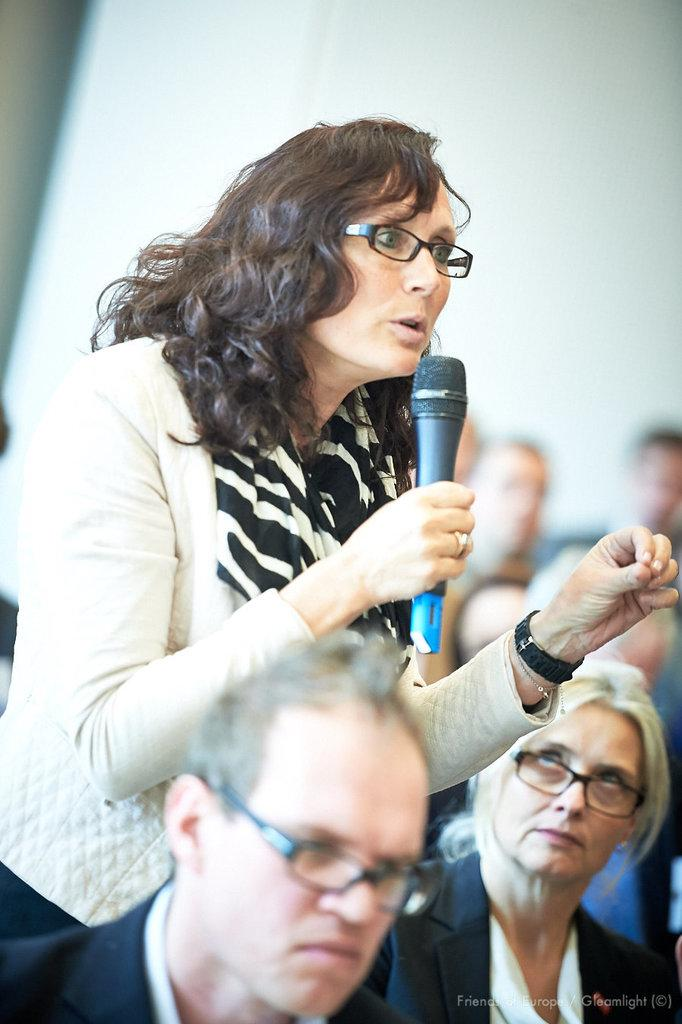What is the main subject of the image? The main subject of the image is a woman. What is the woman doing in the image? The woman is standing and speaking something. Are there any other people in the image? Yes, there are other people around the woman. What color are the eggs in the image? There are no eggs present in the image. What time is it according to the clock in the image? There is no clock present in the image. 